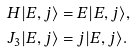<formula> <loc_0><loc_0><loc_500><loc_500>H | E , j \rangle & = E | E , j \rangle , \\ J _ { 3 } | E , j \rangle & = j | E , j \rangle .</formula> 